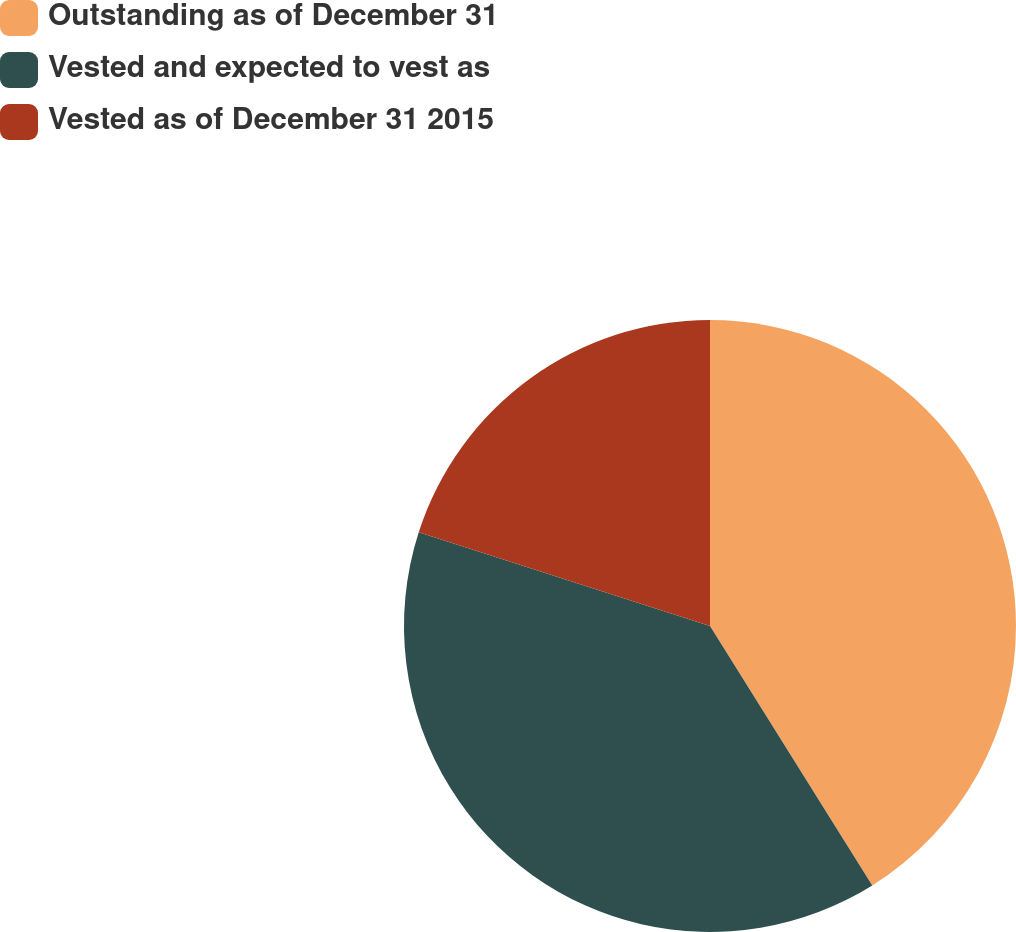<chart> <loc_0><loc_0><loc_500><loc_500><pie_chart><fcel>Outstanding as of December 31<fcel>Vested and expected to vest as<fcel>Vested as of December 31 2015<nl><fcel>41.1%<fcel>38.85%<fcel>20.04%<nl></chart> 